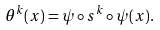Convert formula to latex. <formula><loc_0><loc_0><loc_500><loc_500>\theta ^ { k } ( x ) = \psi \circ s ^ { k } \circ \psi ( x ) .</formula> 